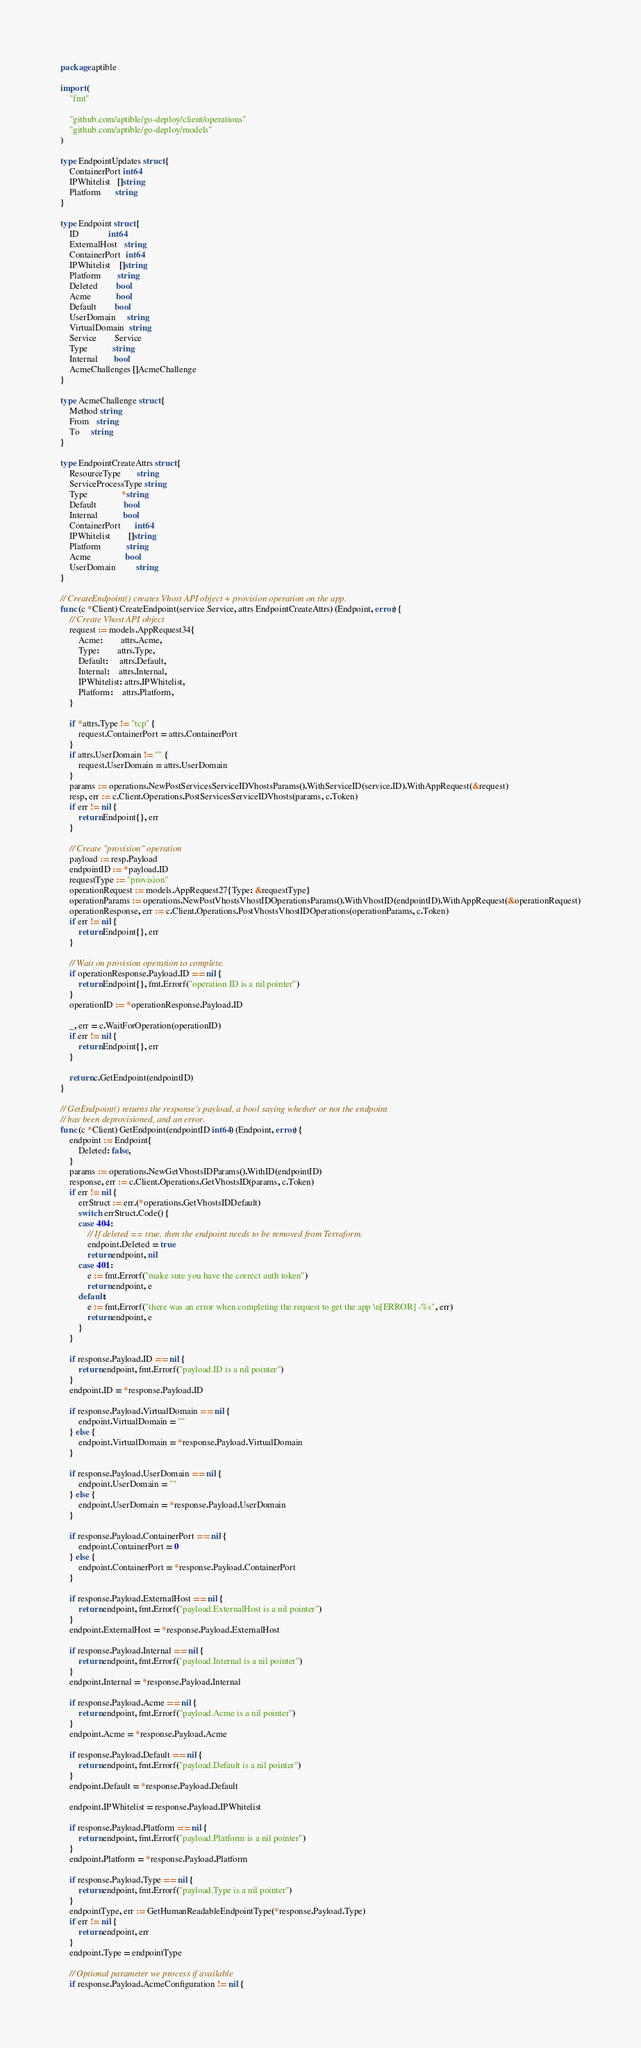Convert code to text. <code><loc_0><loc_0><loc_500><loc_500><_Go_>package aptible

import (
	"fmt"

	"github.com/aptible/go-deploy/client/operations"
	"github.com/aptible/go-deploy/models"
)

type EndpointUpdates struct {
	ContainerPort int64
	IPWhitelist   []string
	Platform      string
}

type Endpoint struct {
	ID             int64
	ExternalHost   string
	ContainerPort  int64
	IPWhitelist    []string
	Platform       string
	Deleted        bool
	Acme           bool
	Default        bool
	UserDomain     string
	VirtualDomain  string
	Service        Service
	Type           string
	Internal       bool
	AcmeChallenges []AcmeChallenge
}

type AcmeChallenge struct {
	Method string
	From   string
	To     string
}

type EndpointCreateAttrs struct {
	ResourceType       string
	ServiceProcessType string
	Type               *string
	Default            bool
	Internal           bool
	ContainerPort      int64
	IPWhitelist        []string
	Platform           string
	Acme               bool
	UserDomain         string
}

// CreateEndpoint() creates Vhost API object + provision operation on the app.
func (c *Client) CreateEndpoint(service Service, attrs EndpointCreateAttrs) (Endpoint, error) {
	// Create Vhost API object
	request := models.AppRequest34{
		Acme:        attrs.Acme,
		Type:        attrs.Type,
		Default:     attrs.Default,
		Internal:    attrs.Internal,
		IPWhitelist: attrs.IPWhitelist,
		Platform:    attrs.Platform,
	}

	if *attrs.Type != "tcp" {
		request.ContainerPort = attrs.ContainerPort
	}
	if attrs.UserDomain != "" {
		request.UserDomain = attrs.UserDomain
	}
	params := operations.NewPostServicesServiceIDVhostsParams().WithServiceID(service.ID).WithAppRequest(&request)
	resp, err := c.Client.Operations.PostServicesServiceIDVhosts(params, c.Token)
	if err != nil {
		return Endpoint{}, err
	}

	// Create "provision" operation
	payload := resp.Payload
	endpointID := *payload.ID
	requestType := "provision"
	operationRequest := models.AppRequest27{Type: &requestType}
	operationParams := operations.NewPostVhostsVhostIDOperationsParams().WithVhostID(endpointID).WithAppRequest(&operationRequest)
	operationResponse, err := c.Client.Operations.PostVhostsVhostIDOperations(operationParams, c.Token)
	if err != nil {
		return Endpoint{}, err
	}

	// Wait on provision operation to complete.
	if operationResponse.Payload.ID == nil {
		return Endpoint{}, fmt.Errorf("operation ID is a nil pointer")
	}
	operationID := *operationResponse.Payload.ID

	_, err = c.WaitForOperation(operationID)
	if err != nil {
		return Endpoint{}, err
	}

	return c.GetEndpoint(endpointID)
}

// GetEndpoint() returns the response's payload, a bool saying whether or not the endpoint
// has been deprovisioned, and an error.
func (c *Client) GetEndpoint(endpointID int64) (Endpoint, error) {
	endpoint := Endpoint{
		Deleted: false,
	}
	params := operations.NewGetVhostsIDParams().WithID(endpointID)
	response, err := c.Client.Operations.GetVhostsID(params, c.Token)
	if err != nil {
		errStruct := err.(*operations.GetVhostsIDDefault)
		switch errStruct.Code() {
		case 404:
			// If deleted == true, then the endpoint needs to be removed from Terraform.
			endpoint.Deleted = true
			return endpoint, nil
		case 401:
			e := fmt.Errorf("make sure you have the correct auth token")
			return endpoint, e
		default:
			e := fmt.Errorf("there was an error when completing the request to get the app \n[ERROR] -%s", err)
			return endpoint, e
		}
	}

	if response.Payload.ID == nil {
		return endpoint, fmt.Errorf("payload.ID is a nil pointer")
	}
	endpoint.ID = *response.Payload.ID

	if response.Payload.VirtualDomain == nil {
		endpoint.VirtualDomain = ""
	} else {
		endpoint.VirtualDomain = *response.Payload.VirtualDomain
	}

	if response.Payload.UserDomain == nil {
		endpoint.UserDomain = ""
	} else {
		endpoint.UserDomain = *response.Payload.UserDomain
	}

	if response.Payload.ContainerPort == nil {
		endpoint.ContainerPort = 0
	} else {
		endpoint.ContainerPort = *response.Payload.ContainerPort
	}

	if response.Payload.ExternalHost == nil {
		return endpoint, fmt.Errorf("payload.ExternalHost is a nil pointer")
	}
	endpoint.ExternalHost = *response.Payload.ExternalHost

	if response.Payload.Internal == nil {
		return endpoint, fmt.Errorf("payload.Internal is a nil pointer")
	}
	endpoint.Internal = *response.Payload.Internal

	if response.Payload.Acme == nil {
		return endpoint, fmt.Errorf("payload.Acme is a nil pointer")
	}
	endpoint.Acme = *response.Payload.Acme

	if response.Payload.Default == nil {
		return endpoint, fmt.Errorf("payload.Default is a nil pointer")
	}
	endpoint.Default = *response.Payload.Default

	endpoint.IPWhitelist = response.Payload.IPWhitelist

	if response.Payload.Platform == nil {
		return endpoint, fmt.Errorf("payload.Platform is a nil pointer")
	}
	endpoint.Platform = *response.Payload.Platform

	if response.Payload.Type == nil {
		return endpoint, fmt.Errorf("payload.Type is a nil pointer")
	}
	endpointType, err := GetHumanReadableEndpointType(*response.Payload.Type)
	if err != nil {
		return endpoint, err
	}
	endpoint.Type = endpointType

	// Optional parameter we process if available
	if response.Payload.AcmeConfiguration != nil {</code> 